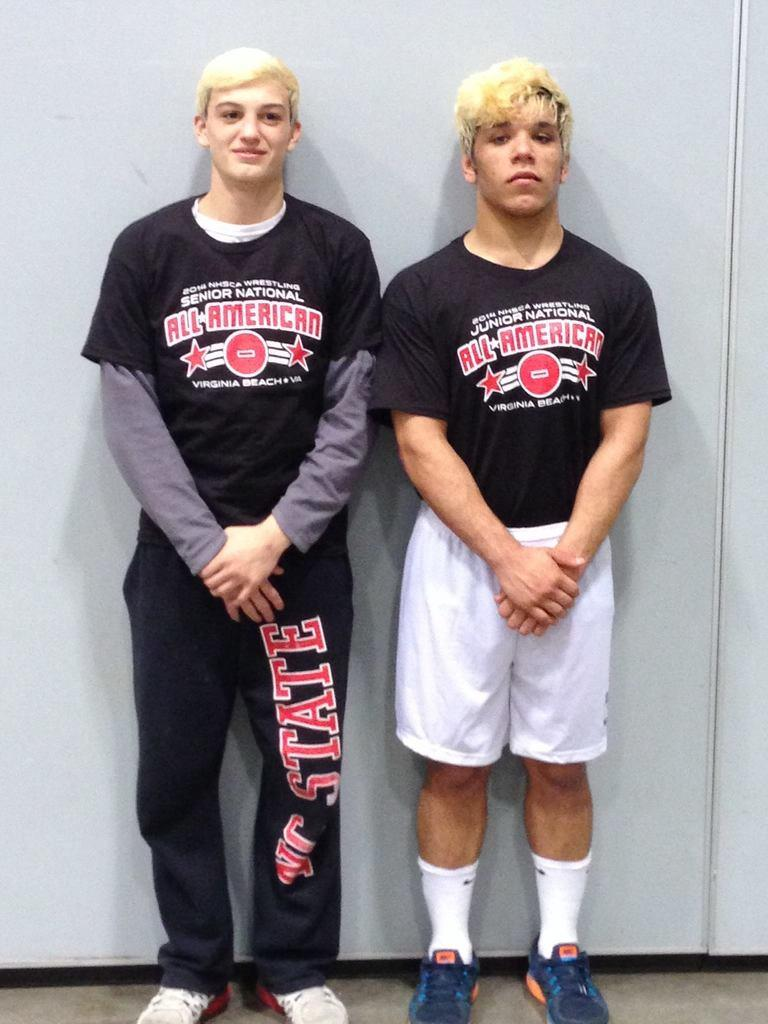<image>
Present a compact description of the photo's key features. A couple of guys leaning on a wall wearing Senior National All American black shirts 